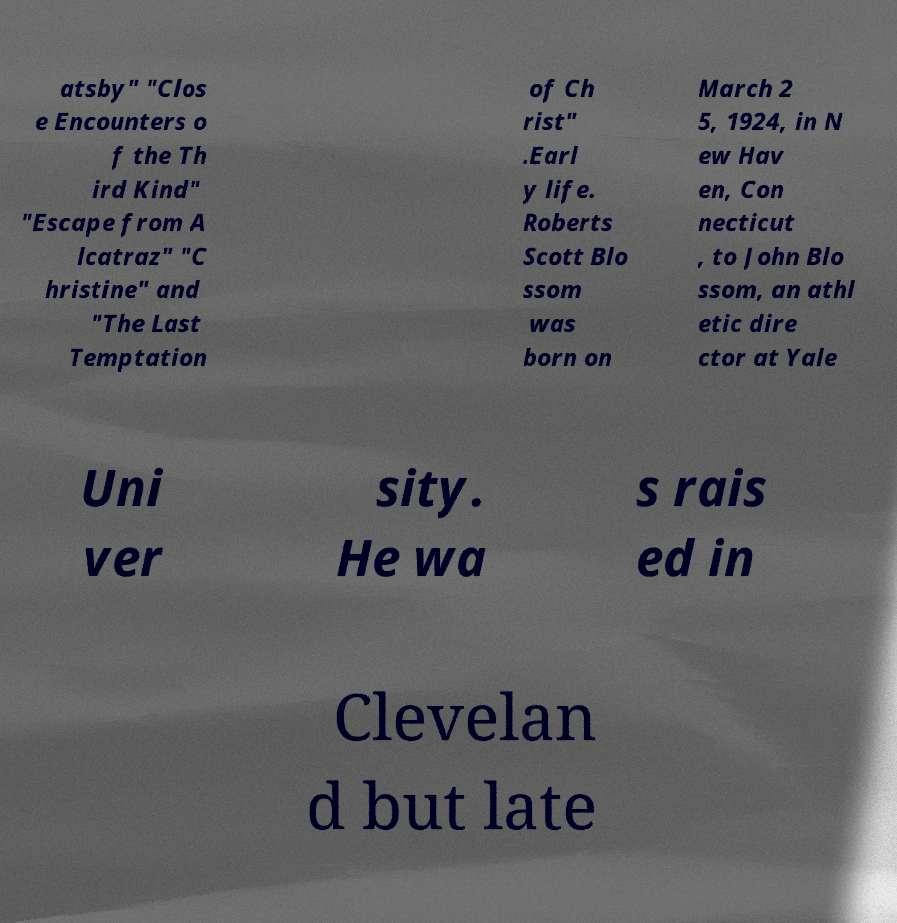Could you extract and type out the text from this image? atsby" "Clos e Encounters o f the Th ird Kind" "Escape from A lcatraz" "C hristine" and "The Last Temptation of Ch rist" .Earl y life. Roberts Scott Blo ssom was born on March 2 5, 1924, in N ew Hav en, Con necticut , to John Blo ssom, an athl etic dire ctor at Yale Uni ver sity. He wa s rais ed in Clevelan d but late 